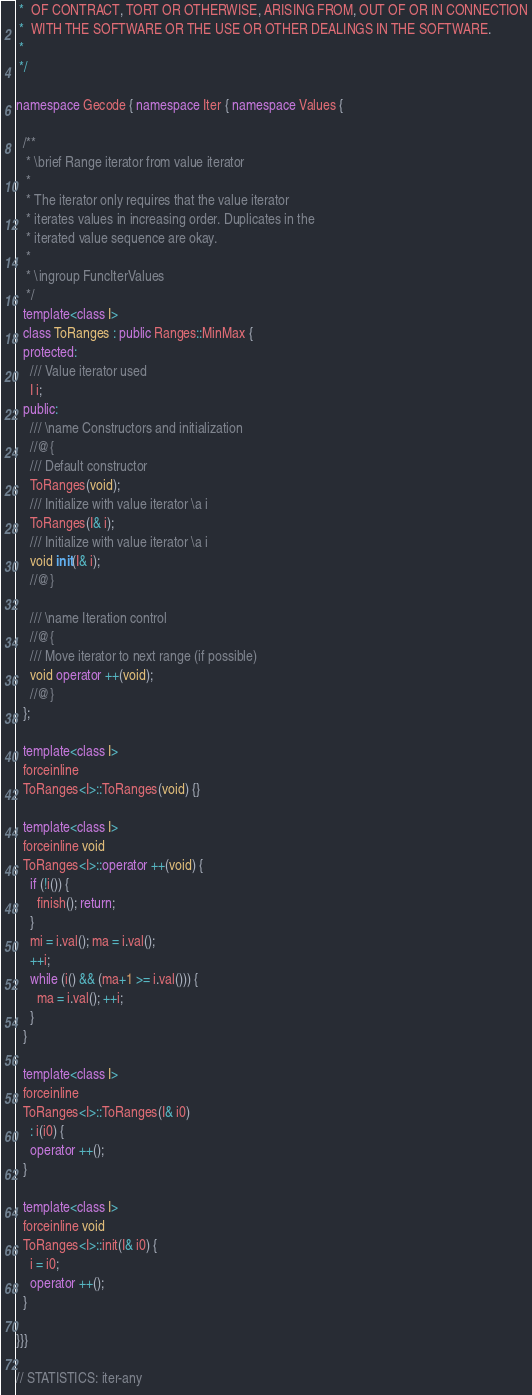<code> <loc_0><loc_0><loc_500><loc_500><_C++_> *  OF CONTRACT, TORT OR OTHERWISE, ARISING FROM, OUT OF OR IN CONNECTION
 *  WITH THE SOFTWARE OR THE USE OR OTHER DEALINGS IN THE SOFTWARE.
 *
 */

namespace Gecode { namespace Iter { namespace Values {

  /**
   * \brief Range iterator from value iterator
   *
   * The iterator only requires that the value iterator
   * iterates values in increasing order. Duplicates in the
   * iterated value sequence are okay.
   *
   * \ingroup FuncIterValues
   */
  template<class I>
  class ToRanges : public Ranges::MinMax {
  protected:
    /// Value iterator used
    I i;
  public:
    /// \name Constructors and initialization
    //@{
    /// Default constructor
    ToRanges(void);
    /// Initialize with value iterator \a i
    ToRanges(I& i);
    /// Initialize with value iterator \a i
    void init(I& i);
    //@}

    /// \name Iteration control
    //@{
    /// Move iterator to next range (if possible)
    void operator ++(void);
    //@}
  };

  template<class I>
  forceinline
  ToRanges<I>::ToRanges(void) {}

  template<class I>
  forceinline void
  ToRanges<I>::operator ++(void) {
    if (!i()) {
      finish(); return;
    }
    mi = i.val(); ma = i.val();
    ++i;
    while (i() && (ma+1 >= i.val())) {
      ma = i.val(); ++i;
    }
  }

  template<class I>
  forceinline
  ToRanges<I>::ToRanges(I& i0)
    : i(i0) {
    operator ++();
  }

  template<class I>
  forceinline void
  ToRanges<I>::init(I& i0) {
    i = i0;
    operator ++();
  }

}}}

// STATISTICS: iter-any

</code> 